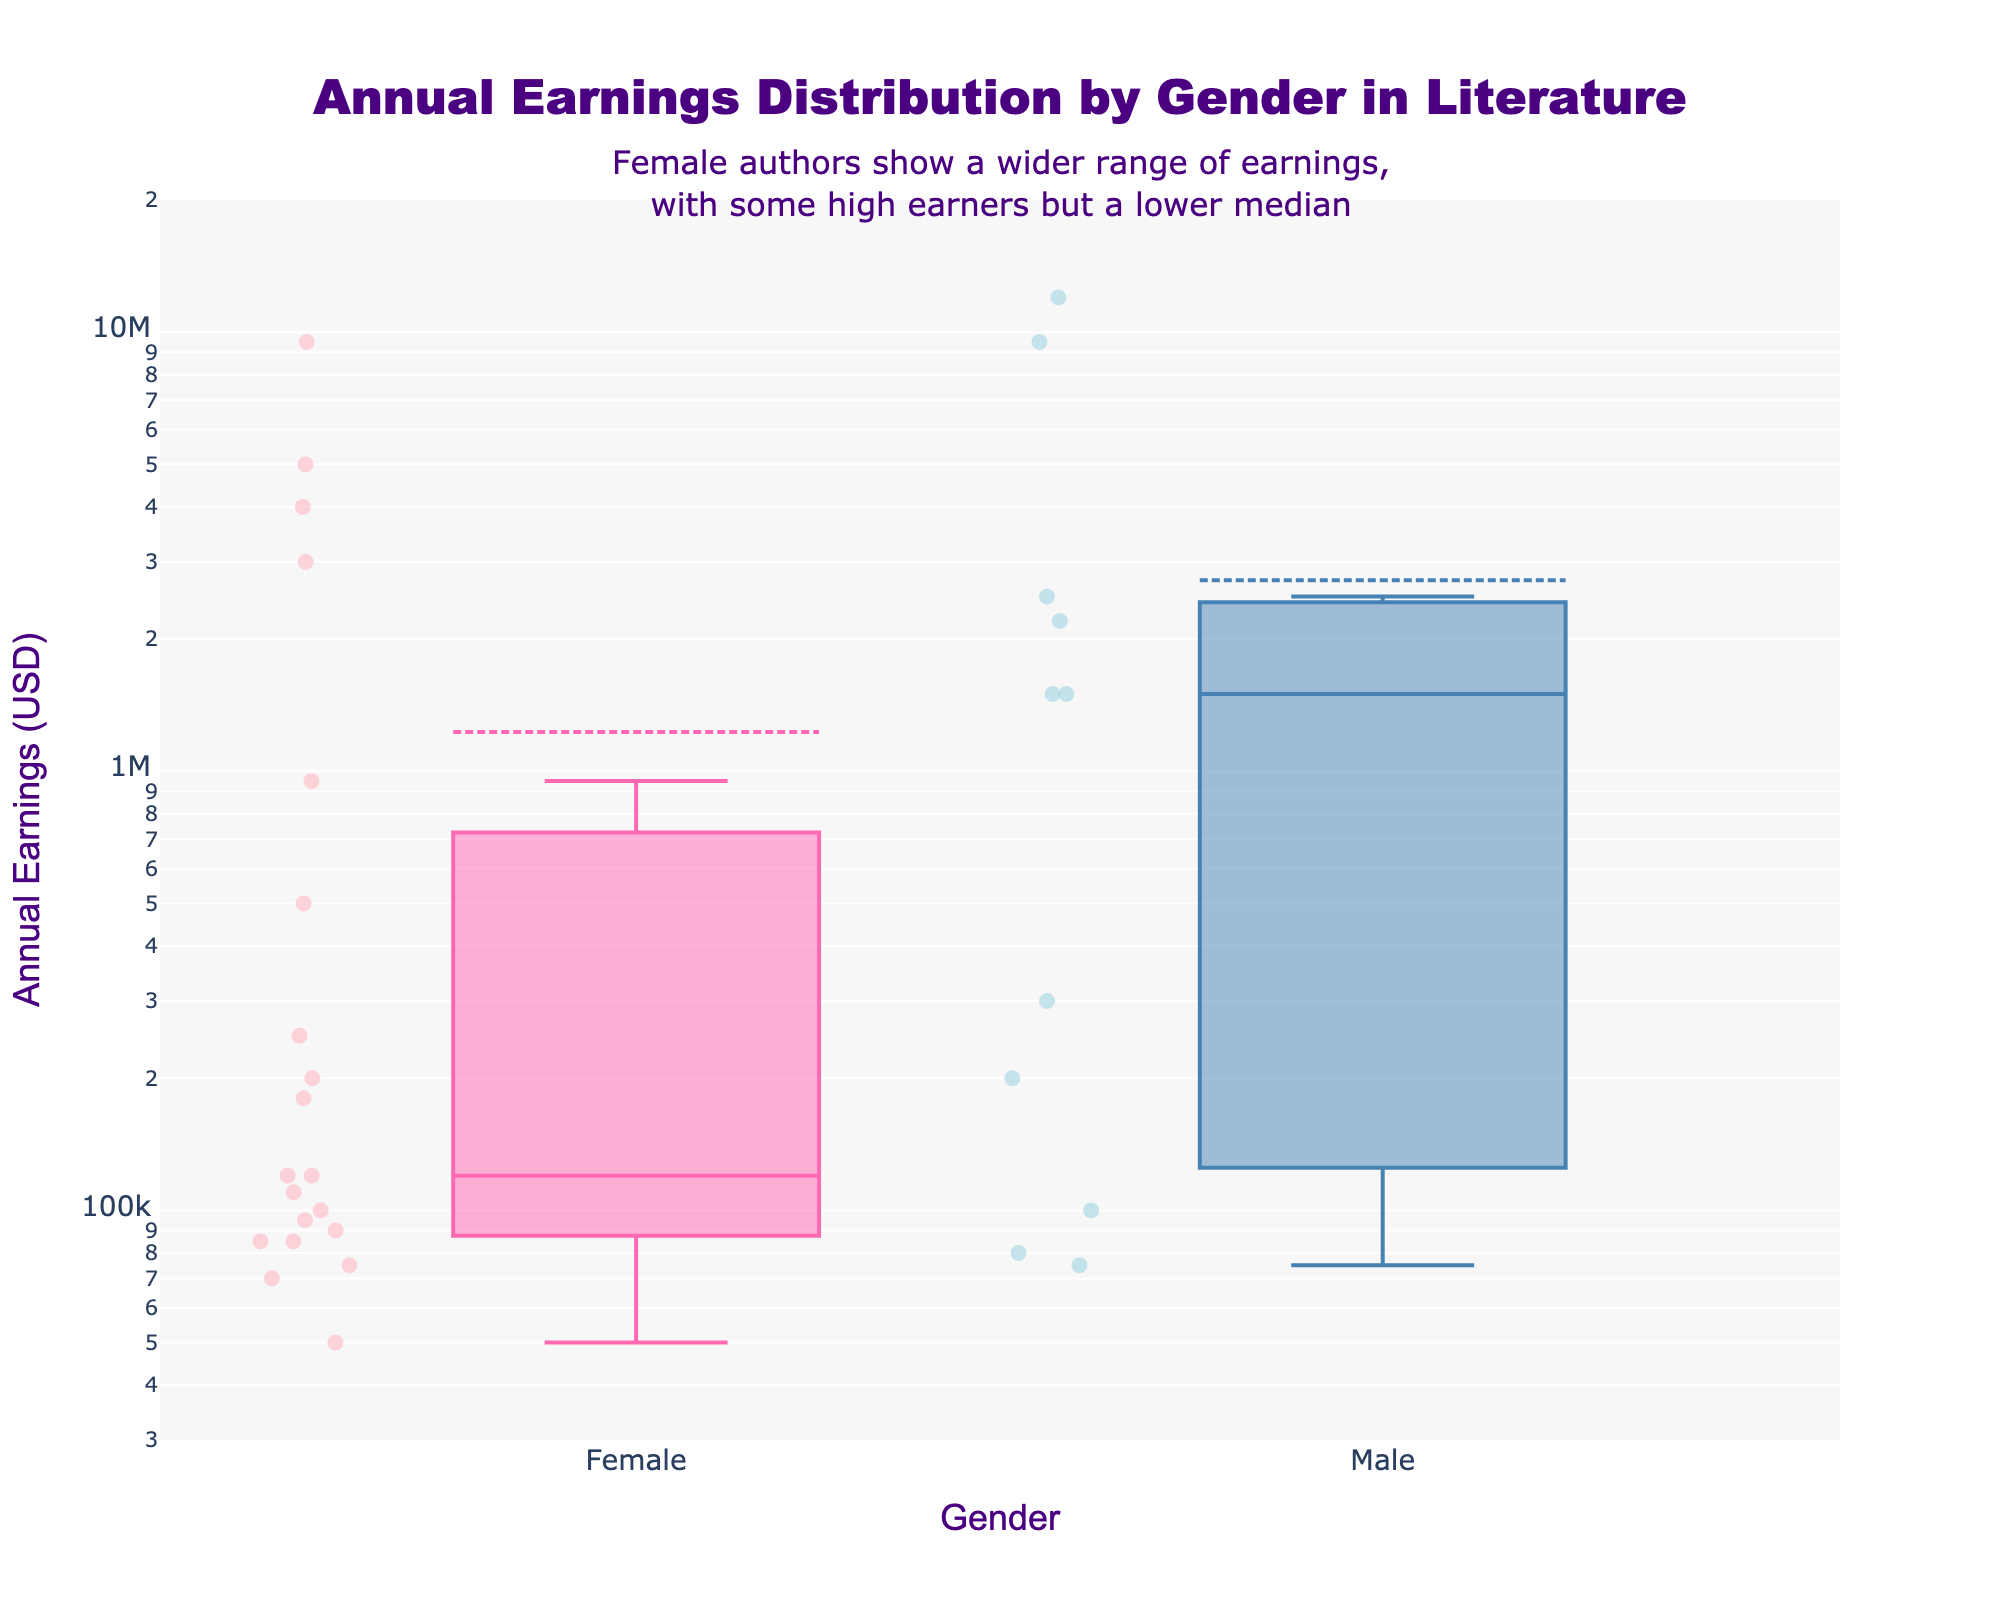what is the title of the plot? The title is displayed at the top center of the plot. It reads, "Annual Earnings Distribution by Gender in Literature".
Answer: Annual Earnings Distribution by Gender in Literature What is the color scheme used for the scatter points representing female authors? The scatter points for female authors are shown in a light pink color, which corresponds to 'rgba(255,192,203,0.7)'.
Answer: light pink Which gender has a higher median annual earnings? The median value can be found by looking at the center line in each box plot. Comparing the center lines of both plots, the male authors have a higher median annual earnings.
Answer: Male How does the range of annual earnings for female authors compare to that of male authors? The range can be assessed by looking at the spread of the box plots. The female authors' earnings have a wider range, extending higher and lower, but with more outliers. The male authors' earnings are more concentrated with fewer extreme lows.
Answer: Female authors have a wider range How many outliers are there in the data for female authors? Outliers are individual points that fall outside the typical spread of the data. There are six outliers for female authors' earnings visually shown on the plot as points scattered away from the main box plot.
Answer: six What is the approximate earnings value for the highest outlier in female authors? The highest outlier for female authors is around the second dot above the main box, visually it is close to $12 million as indicated in the figure.
Answer: $12 million Which genre represents the highest earnings for male authors? To answer this, identify distinct earnings data points on the male box plot and correlate with known high earners. "George R.R. Martin" is known for fantasy, at about $12 million.
Answer: Fantasy Which gender exhibits the greater variability in their annual earnings, and how is this illustrated in the plot? Variability is shown by the spread and the presence of outliers. Female authors exhibit greater variability as their box plot is wider and includes several outliers.
Answer: Female What is a notable observation about the $300,000 earning mark on the plot? A single isolated point (an outlier) representing male authors is clearly visible at the $300,000 mark, which corresponds to Arthur Conan Doyle's earnings in mystery.
Answer: Single outlier at $300,000 for Male What insight does the annotation in the figure convey about female authors? The annotation explains that female authors have a wider range of earnings, some achieving very high, but overall, the median is lower compared to their male counterparts.
Answer: Wider range, lower median 